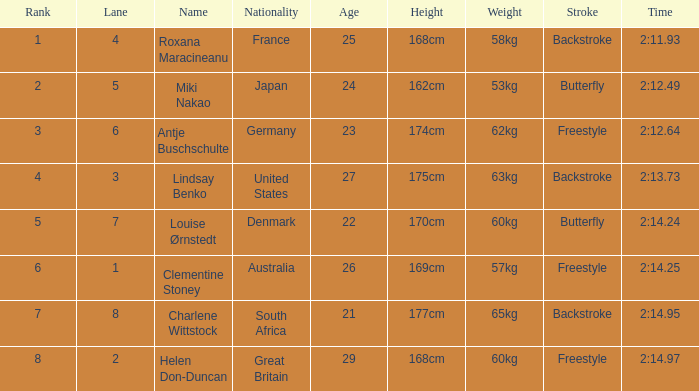What is the average Rank for a lane smaller than 3 with a nationality of Australia? 6.0. 